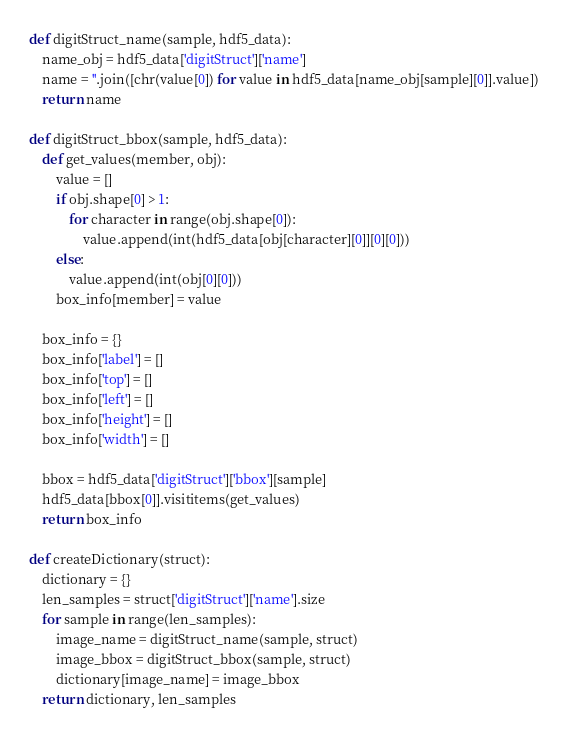<code> <loc_0><loc_0><loc_500><loc_500><_Python_>def digitStruct_name(sample, hdf5_data):
    name_obj = hdf5_data['digitStruct']['name']
    name = ''.join([chr(value[0]) for value in hdf5_data[name_obj[sample][0]].value])
    return name

def digitStruct_bbox(sample, hdf5_data):
    def get_values(member, obj):
        value = []
        if obj.shape[0] > 1:
            for character in range(obj.shape[0]):
                value.append(int(hdf5_data[obj[character][0]][0][0]))
        else:
            value.append(int(obj[0][0]))
        box_info[member] = value

    box_info = {}
    box_info['label'] = []
    box_info['top'] = []
    box_info['left'] = []
    box_info['height'] = []
    box_info['width'] = []

    bbox = hdf5_data['digitStruct']['bbox'][sample]
    hdf5_data[bbox[0]].visititems(get_values)
    return box_info

def createDictionary(struct):
    dictionary = {}
    len_samples = struct['digitStruct']['name'].size
    for sample in range(len_samples):
        image_name = digitStruct_name(sample, struct)
        image_bbox = digitStruct_bbox(sample, struct)
        dictionary[image_name] = image_bbox
    return dictionary, len_samples
</code> 